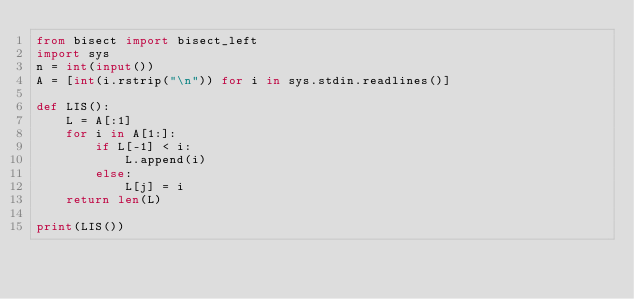<code> <loc_0><loc_0><loc_500><loc_500><_Python_>from bisect import bisect_left
import sys
n = int(input())
A = [int(i.rstrip("\n")) for i in sys.stdin.readlines()]

def LIS():
    L = A[:1]
    for i in A[1:]:
        if L[-1] < i:
            L.append(i)
        else:
            L[j] = i
    return len(L)

print(LIS())</code> 